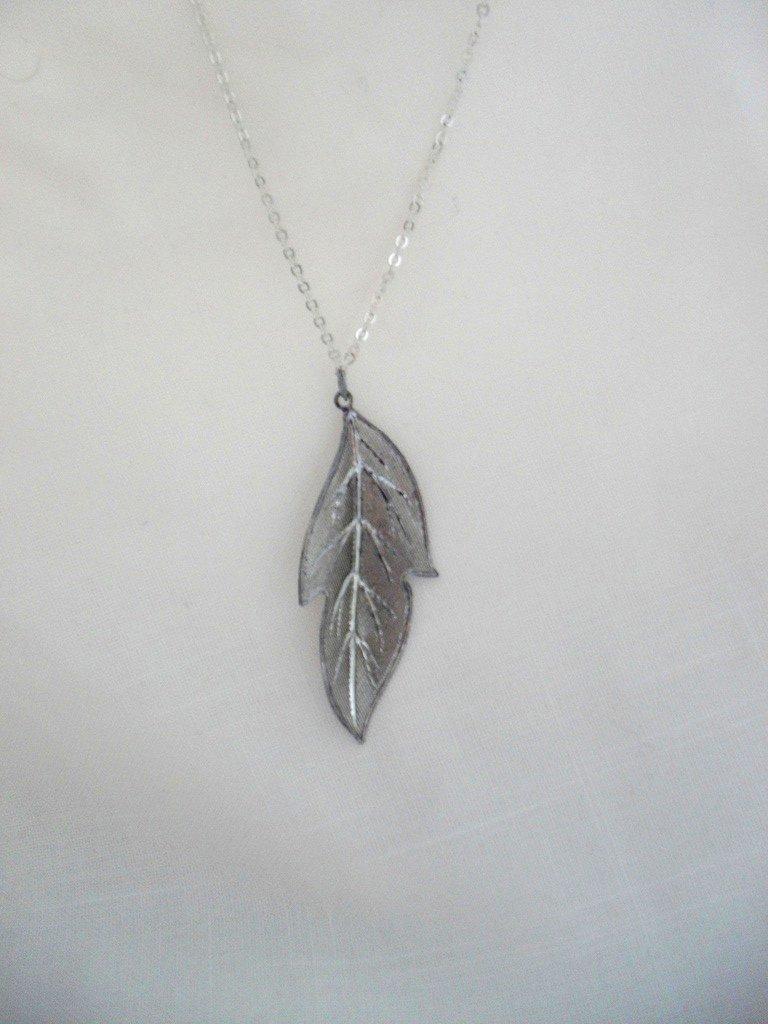Could you give a brief overview of what you see in this image? Here we can see a pendant and a chain on a white platform. 